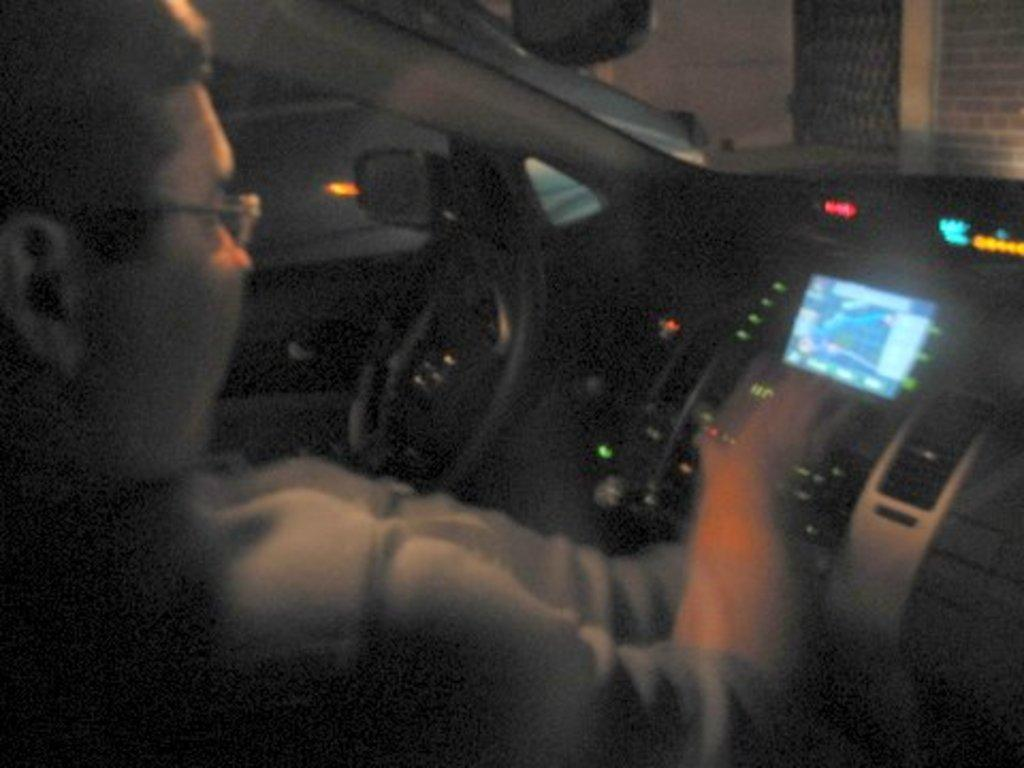What is the person in the image doing? The person is in a car in the image. What structure can be seen in the image besides the car? There is a building in the image. What feature is present on the building? The building has drills on it. What type of soap is being used to clean the building in the image? There is no soap or cleaning activity present in the image. What type of cart is being used to transport the person in the image? There is no cart present in the image; the person is in a car. 